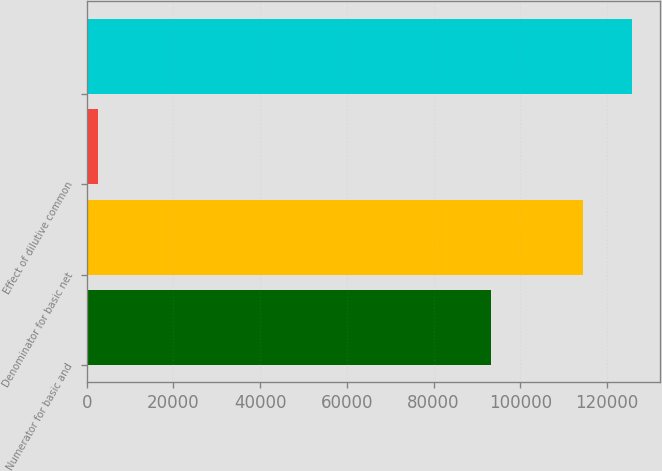Convert chart. <chart><loc_0><loc_0><loc_500><loc_500><bar_chart><fcel>Numerator for basic and<fcel>Denominator for basic net<fcel>Effect of dilutive common<fcel>Unnamed: 3<nl><fcel>93233<fcel>114375<fcel>2653<fcel>125812<nl></chart> 